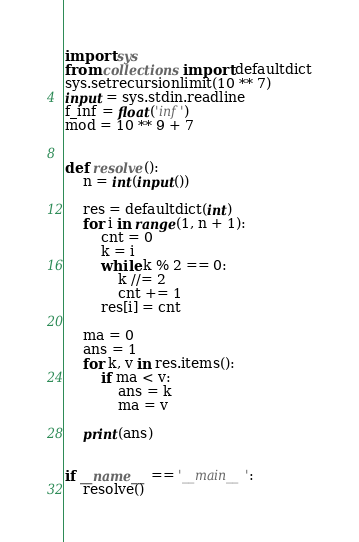<code> <loc_0><loc_0><loc_500><loc_500><_Python_>import sys
from collections import defaultdict
sys.setrecursionlimit(10 ** 7)
input = sys.stdin.readline
f_inf = float('inf')
mod = 10 ** 9 + 7


def resolve():
    n = int(input())

    res = defaultdict(int)
    for i in range(1, n + 1):
        cnt = 0
        k = i
        while k % 2 == 0:
            k //= 2
            cnt += 1
        res[i] = cnt

    ma = 0
    ans = 1
    for k, v in res.items():
        if ma < v:
            ans = k
            ma = v

    print(ans)


if __name__ == '__main__':
    resolve()
</code> 